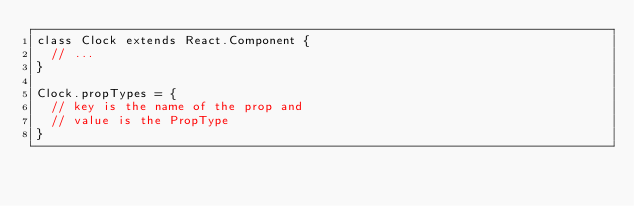Convert code to text. <code><loc_0><loc_0><loc_500><loc_500><_JavaScript_>class Clock extends React.Component {
  // ...
}

Clock.propTypes = {
  // key is the name of the prop and
  // value is the PropType
}</code> 